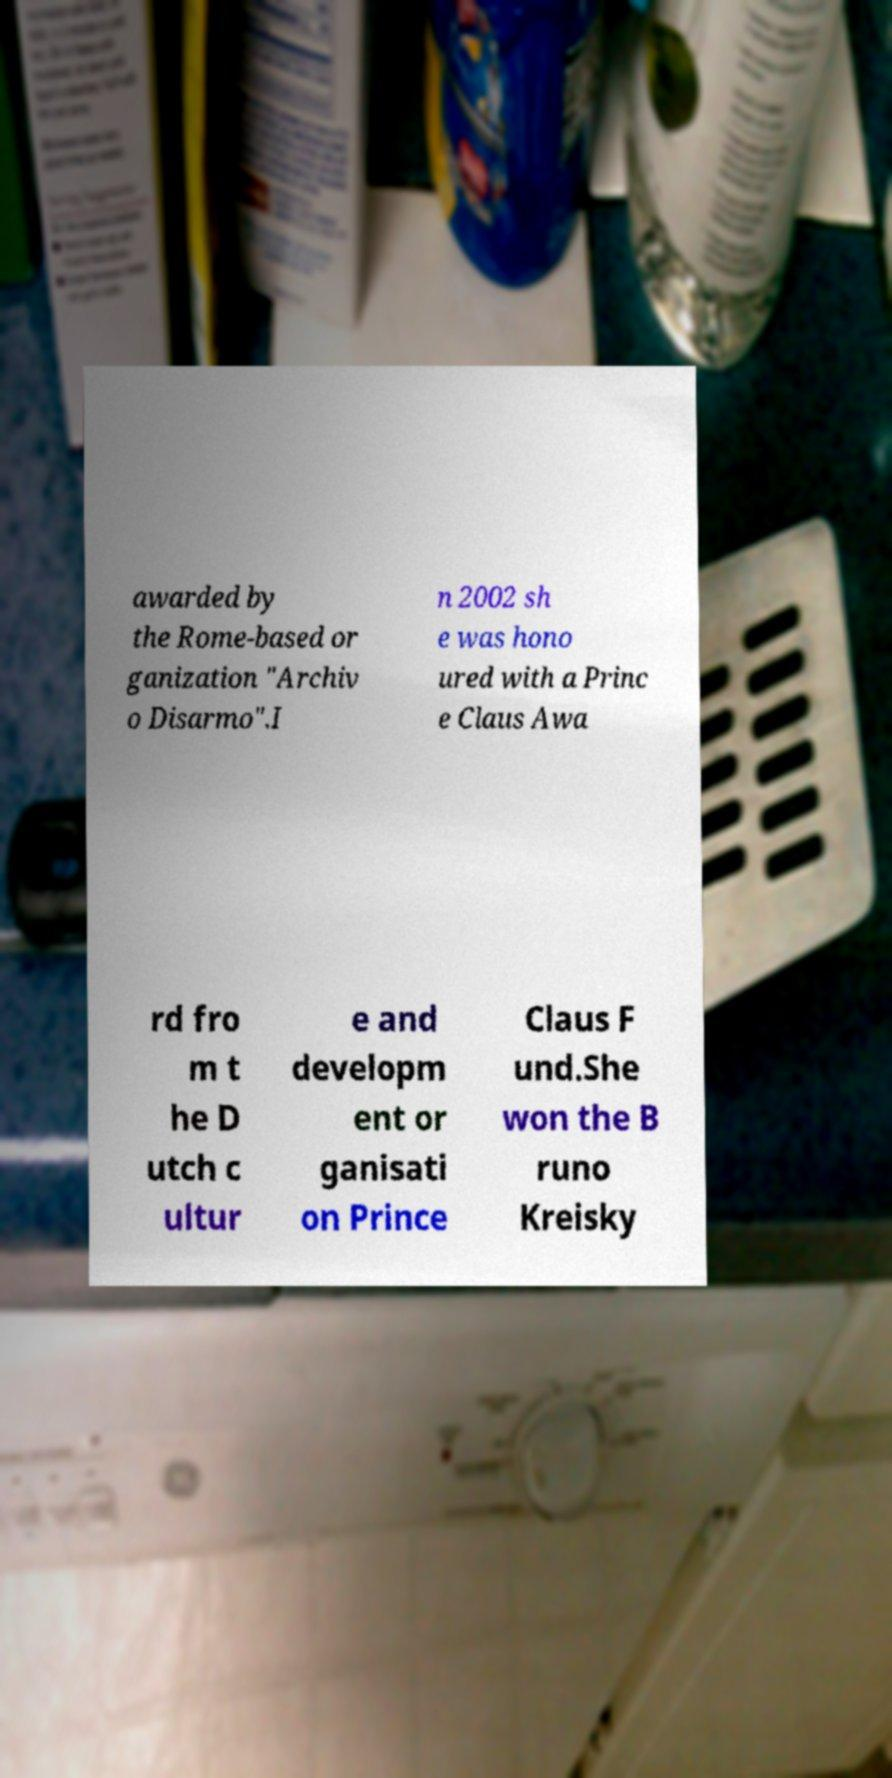What messages or text are displayed in this image? I need them in a readable, typed format. awarded by the Rome-based or ganization "Archiv o Disarmo".I n 2002 sh e was hono ured with a Princ e Claus Awa rd fro m t he D utch c ultur e and developm ent or ganisati on Prince Claus F und.She won the B runo Kreisky 